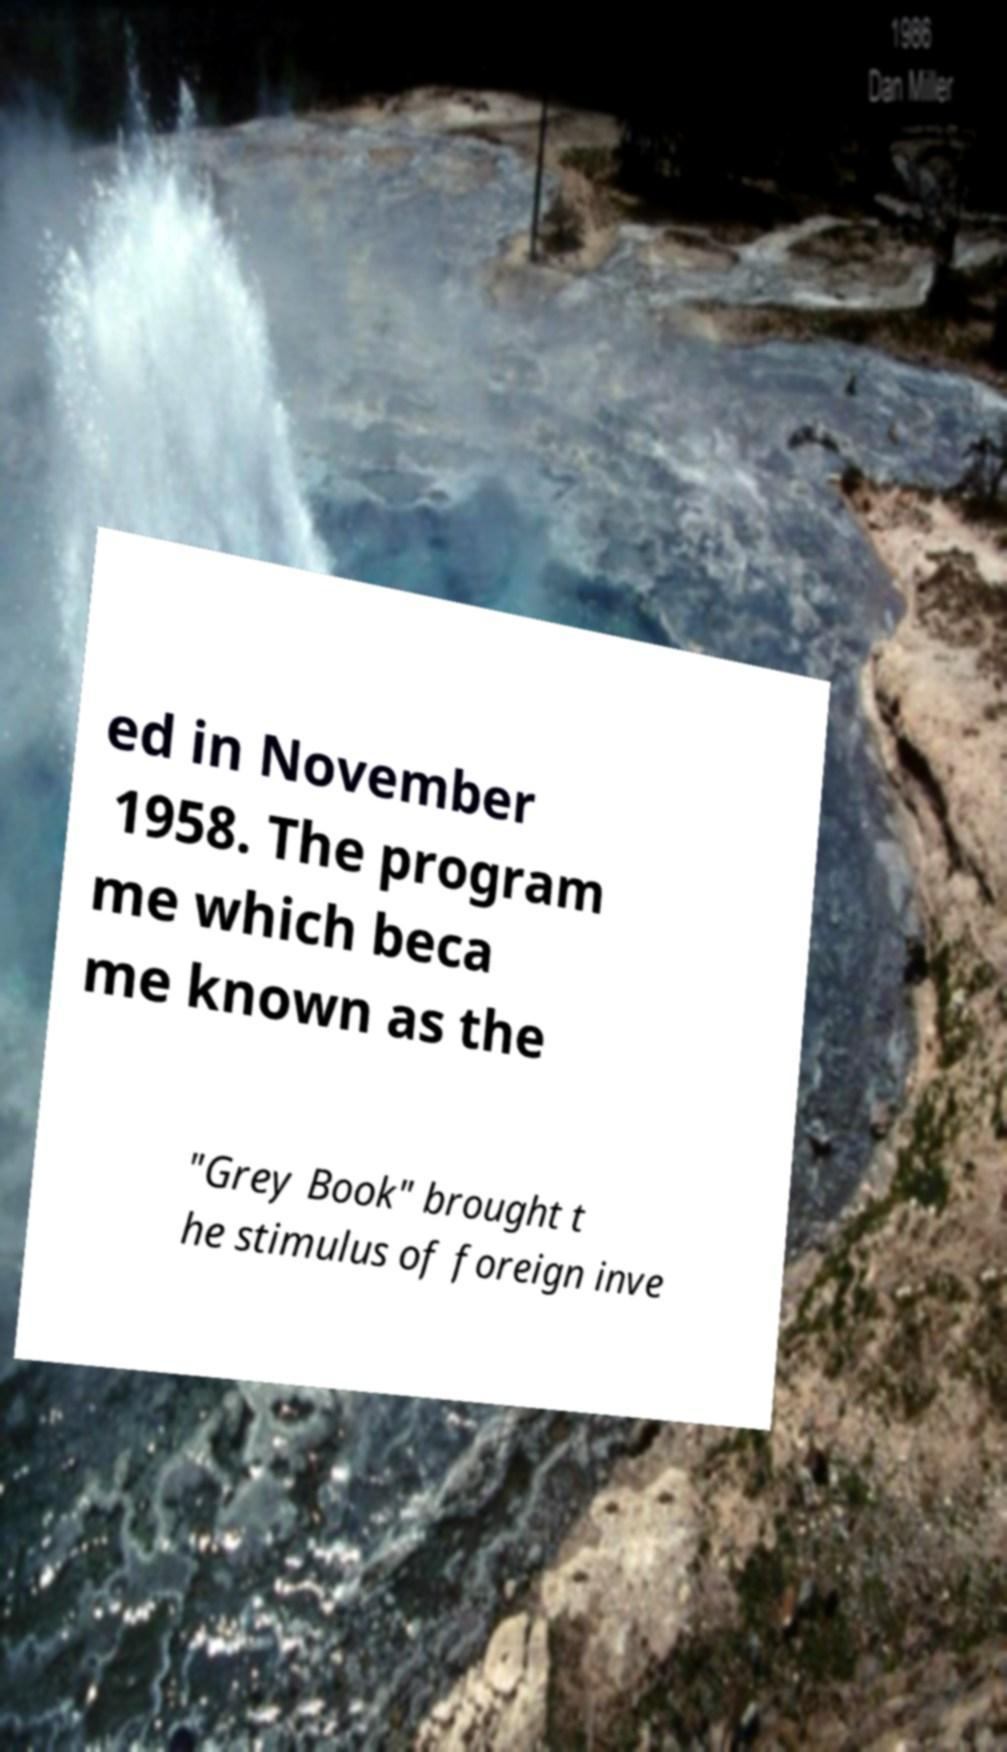For documentation purposes, I need the text within this image transcribed. Could you provide that? ed in November 1958. The program me which beca me known as the "Grey Book" brought t he stimulus of foreign inve 